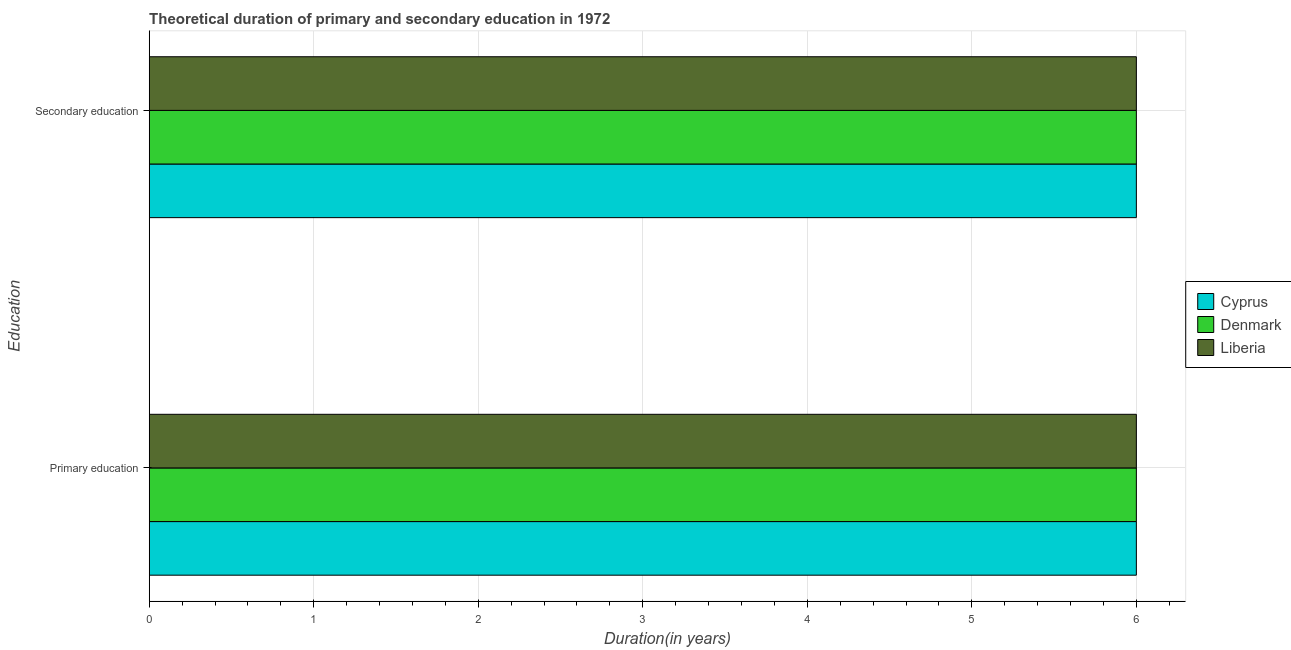How many groups of bars are there?
Your answer should be compact. 2. How many bars are there on the 2nd tick from the bottom?
Provide a short and direct response. 3. What is the duration of primary education in Cyprus?
Offer a very short reply. 6. Across all countries, what is the maximum duration of primary education?
Offer a terse response. 6. Across all countries, what is the minimum duration of secondary education?
Ensure brevity in your answer.  6. In which country was the duration of secondary education maximum?
Your answer should be compact. Cyprus. In which country was the duration of secondary education minimum?
Ensure brevity in your answer.  Cyprus. What is the total duration of secondary education in the graph?
Ensure brevity in your answer.  18. What is the difference between the duration of primary education in Cyprus and that in Liberia?
Offer a terse response. 0. What is the difference between the duration of secondary education and duration of primary education in Liberia?
Provide a short and direct response. 0. What is the ratio of the duration of primary education in Denmark to that in Cyprus?
Your answer should be very brief. 1. Is the duration of primary education in Liberia less than that in Denmark?
Your answer should be very brief. No. What does the 1st bar from the top in Secondary education represents?
Keep it short and to the point. Liberia. How many bars are there?
Give a very brief answer. 6. Are all the bars in the graph horizontal?
Your response must be concise. Yes. Are the values on the major ticks of X-axis written in scientific E-notation?
Ensure brevity in your answer.  No. Does the graph contain any zero values?
Your answer should be compact. No. Does the graph contain grids?
Ensure brevity in your answer.  Yes. How are the legend labels stacked?
Your answer should be very brief. Vertical. What is the title of the graph?
Ensure brevity in your answer.  Theoretical duration of primary and secondary education in 1972. Does "Latvia" appear as one of the legend labels in the graph?
Your response must be concise. No. What is the label or title of the X-axis?
Offer a terse response. Duration(in years). What is the label or title of the Y-axis?
Make the answer very short. Education. What is the Duration(in years) of Cyprus in Primary education?
Your answer should be very brief. 6. What is the Duration(in years) in Denmark in Primary education?
Provide a succinct answer. 6. What is the Duration(in years) of Denmark in Secondary education?
Your response must be concise. 6. What is the Duration(in years) of Liberia in Secondary education?
Keep it short and to the point. 6. Across all Education, what is the maximum Duration(in years) in Cyprus?
Make the answer very short. 6. Across all Education, what is the minimum Duration(in years) in Cyprus?
Keep it short and to the point. 6. Across all Education, what is the minimum Duration(in years) of Denmark?
Make the answer very short. 6. What is the total Duration(in years) in Cyprus in the graph?
Offer a very short reply. 12. What is the difference between the Duration(in years) of Cyprus in Primary education and that in Secondary education?
Ensure brevity in your answer.  0. What is the average Duration(in years) of Denmark per Education?
Offer a terse response. 6. What is the difference between the Duration(in years) in Cyprus and Duration(in years) in Liberia in Primary education?
Your answer should be very brief. 0. What is the difference between the Duration(in years) of Denmark and Duration(in years) of Liberia in Primary education?
Provide a short and direct response. 0. What is the difference between the Duration(in years) of Cyprus and Duration(in years) of Liberia in Secondary education?
Keep it short and to the point. 0. What is the difference between the Duration(in years) of Denmark and Duration(in years) of Liberia in Secondary education?
Keep it short and to the point. 0. What is the ratio of the Duration(in years) of Denmark in Primary education to that in Secondary education?
Keep it short and to the point. 1. What is the ratio of the Duration(in years) of Liberia in Primary education to that in Secondary education?
Offer a very short reply. 1. What is the difference between the highest and the second highest Duration(in years) of Cyprus?
Offer a very short reply. 0. What is the difference between the highest and the lowest Duration(in years) of Cyprus?
Offer a terse response. 0. What is the difference between the highest and the lowest Duration(in years) of Denmark?
Provide a succinct answer. 0. 